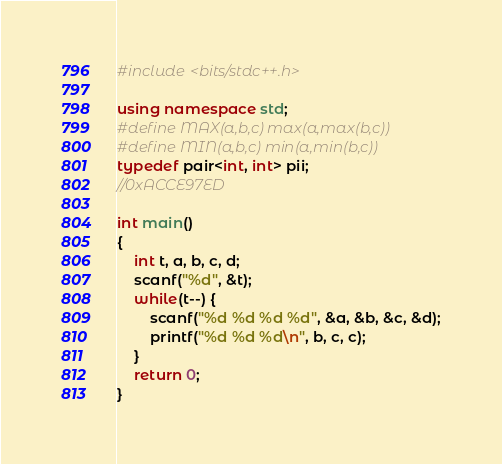<code> <loc_0><loc_0><loc_500><loc_500><_C++_>#include <bits/stdc++.h>

using namespace std;
#define MAX(a,b,c) max(a,max(b,c))
#define MIN(a,b,c) min(a,min(b,c))
typedef pair<int, int> pii;
//0xACCE97ED

int main()
{
	int t, a, b, c, d;
	scanf("%d", &t);
	while(t--) {
		scanf("%d %d %d %d", &a, &b, &c, &d);
		printf("%d %d %d\n", b, c, c);
	}
	return 0;
}</code> 